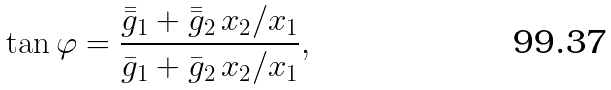<formula> <loc_0><loc_0><loc_500><loc_500>\tan \varphi = \frac { \bar { \bar { g } } _ { 1 } + \bar { \bar { g } } _ { 2 } \, x _ { 2 } / x _ { 1 } } { \bar { g } _ { 1 } + \bar { g } _ { 2 } \, x _ { 2 } / x _ { 1 } } ,</formula> 